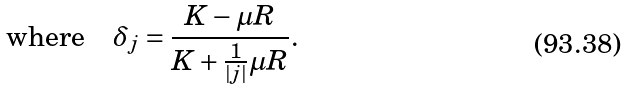Convert formula to latex. <formula><loc_0><loc_0><loc_500><loc_500>\text {where} \quad \delta _ { j } = \frac { K - \mu R } { K + \frac { 1 } { | j | } \mu R } .</formula> 